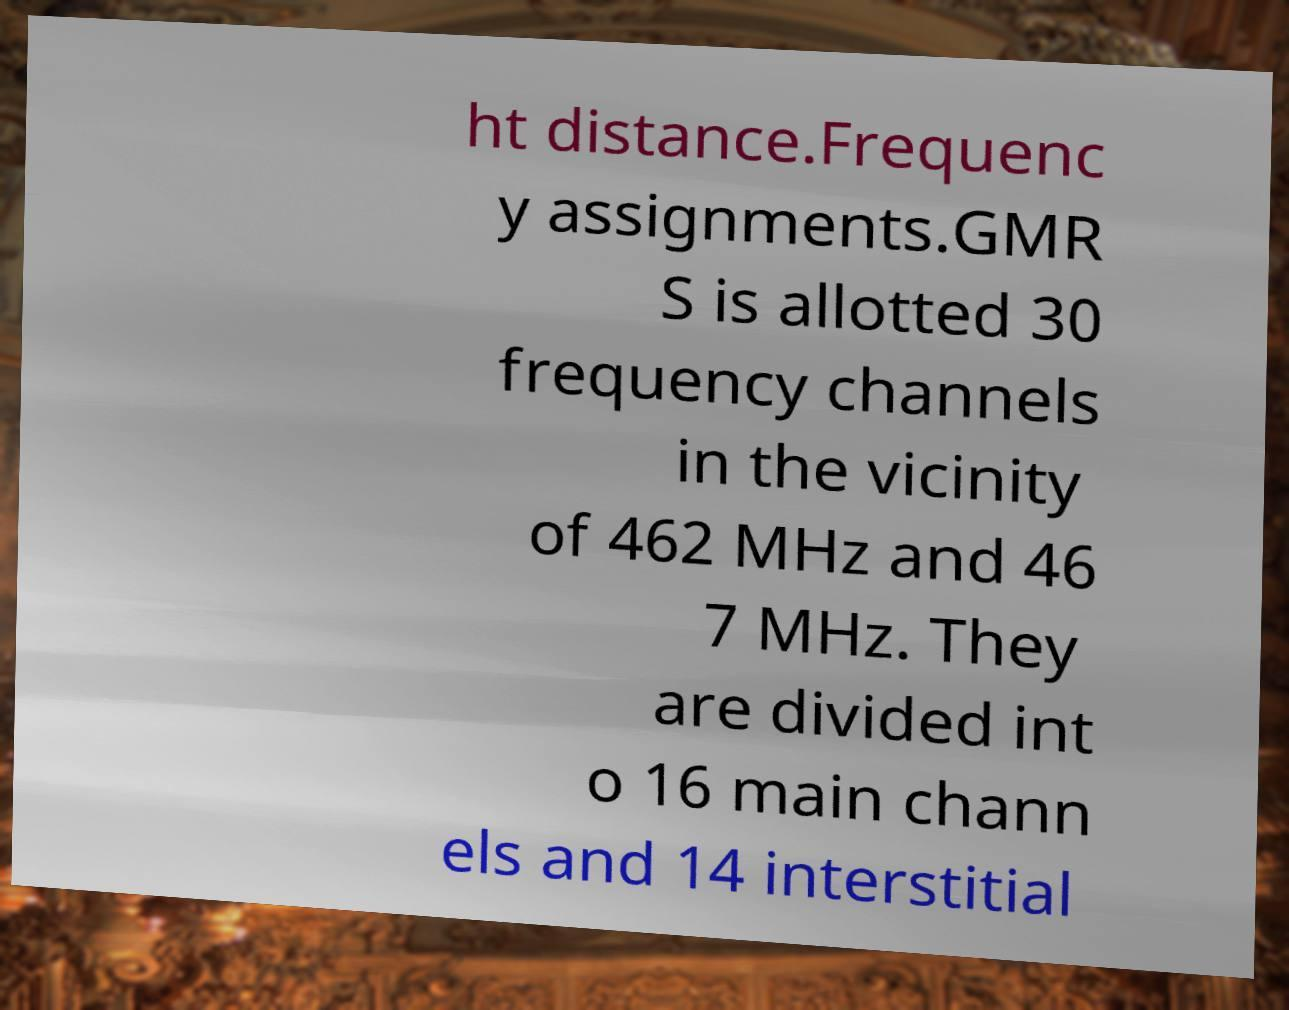There's text embedded in this image that I need extracted. Can you transcribe it verbatim? ht distance.Frequenc y assignments.GMR S is allotted 30 frequency channels in the vicinity of 462 MHz and 46 7 MHz. They are divided int o 16 main chann els and 14 interstitial 